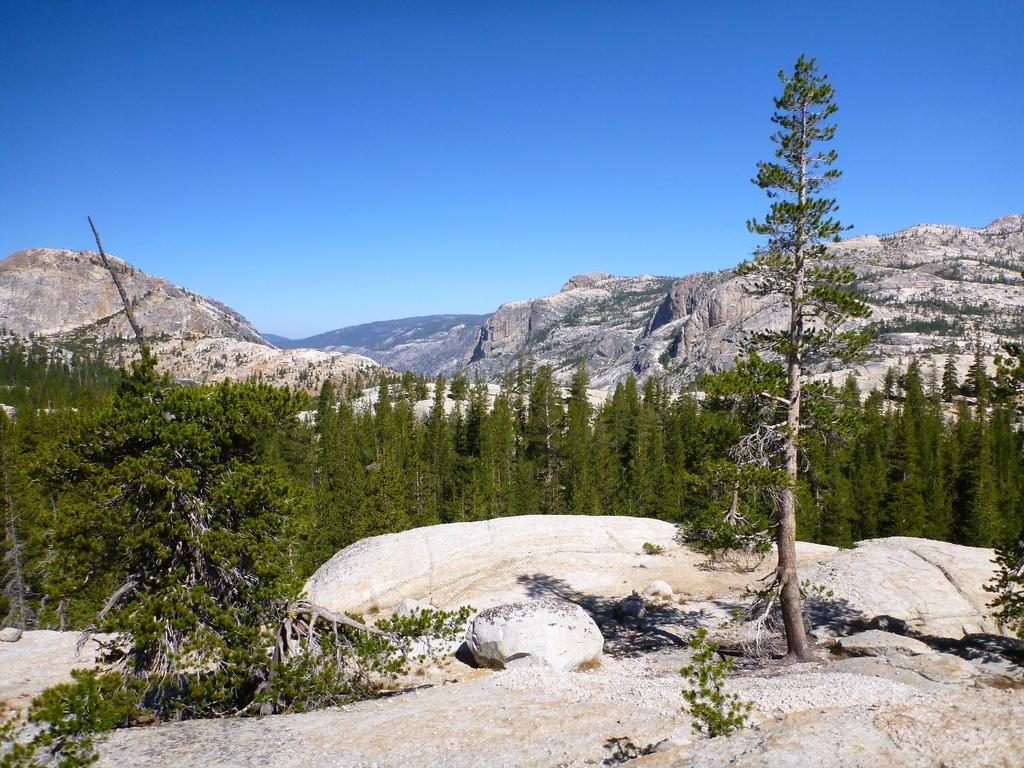What type of vegetation is in the front of the image? There are trees in the front of the image. What type of landscape feature can be seen in the background of the image? There are mountains visible in the background of the image. What else is visible in the background of the image? The sky is visible in the background of the image. Where is the zebra located in the image? There is no zebra present in the image. Can you tell me how many faucets are visible in the image? There are no faucets present in the image. 